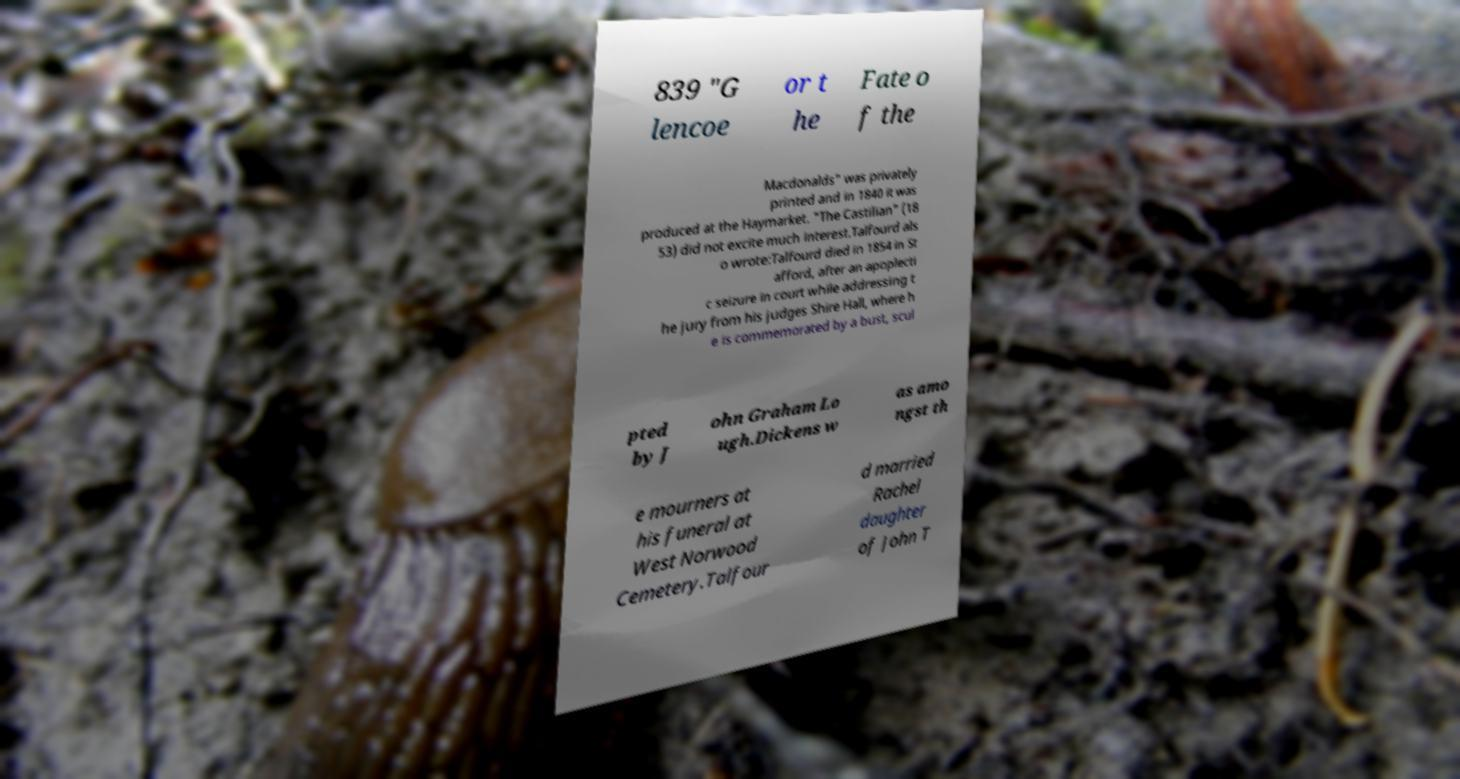What messages or text are displayed in this image? I need them in a readable, typed format. 839 "G lencoe or t he Fate o f the Macdonalds" was privately printed and in 1840 it was produced at the Haymarket. "The Castilian" (18 53) did not excite much interest.Talfourd als o wrote:Talfourd died in 1854 in St afford, after an apoplecti c seizure in court while addressing t he jury from his judges Shire Hall, where h e is commemorated by a bust, scul pted by J ohn Graham Lo ugh.Dickens w as amo ngst th e mourners at his funeral at West Norwood Cemetery.Talfour d married Rachel daughter of John T 